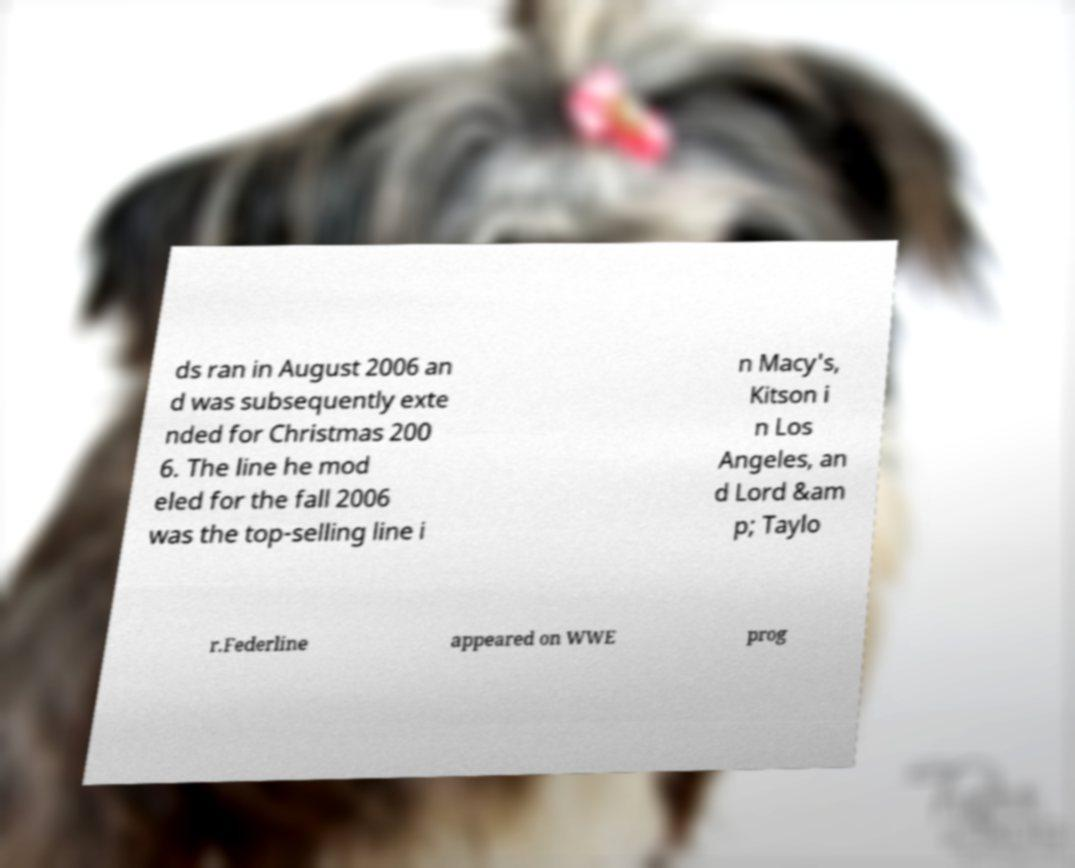Can you accurately transcribe the text from the provided image for me? ds ran in August 2006 an d was subsequently exte nded for Christmas 200 6. The line he mod eled for the fall 2006 was the top-selling line i n Macy's, Kitson i n Los Angeles, an d Lord &am p; Taylo r.Federline appeared on WWE prog 